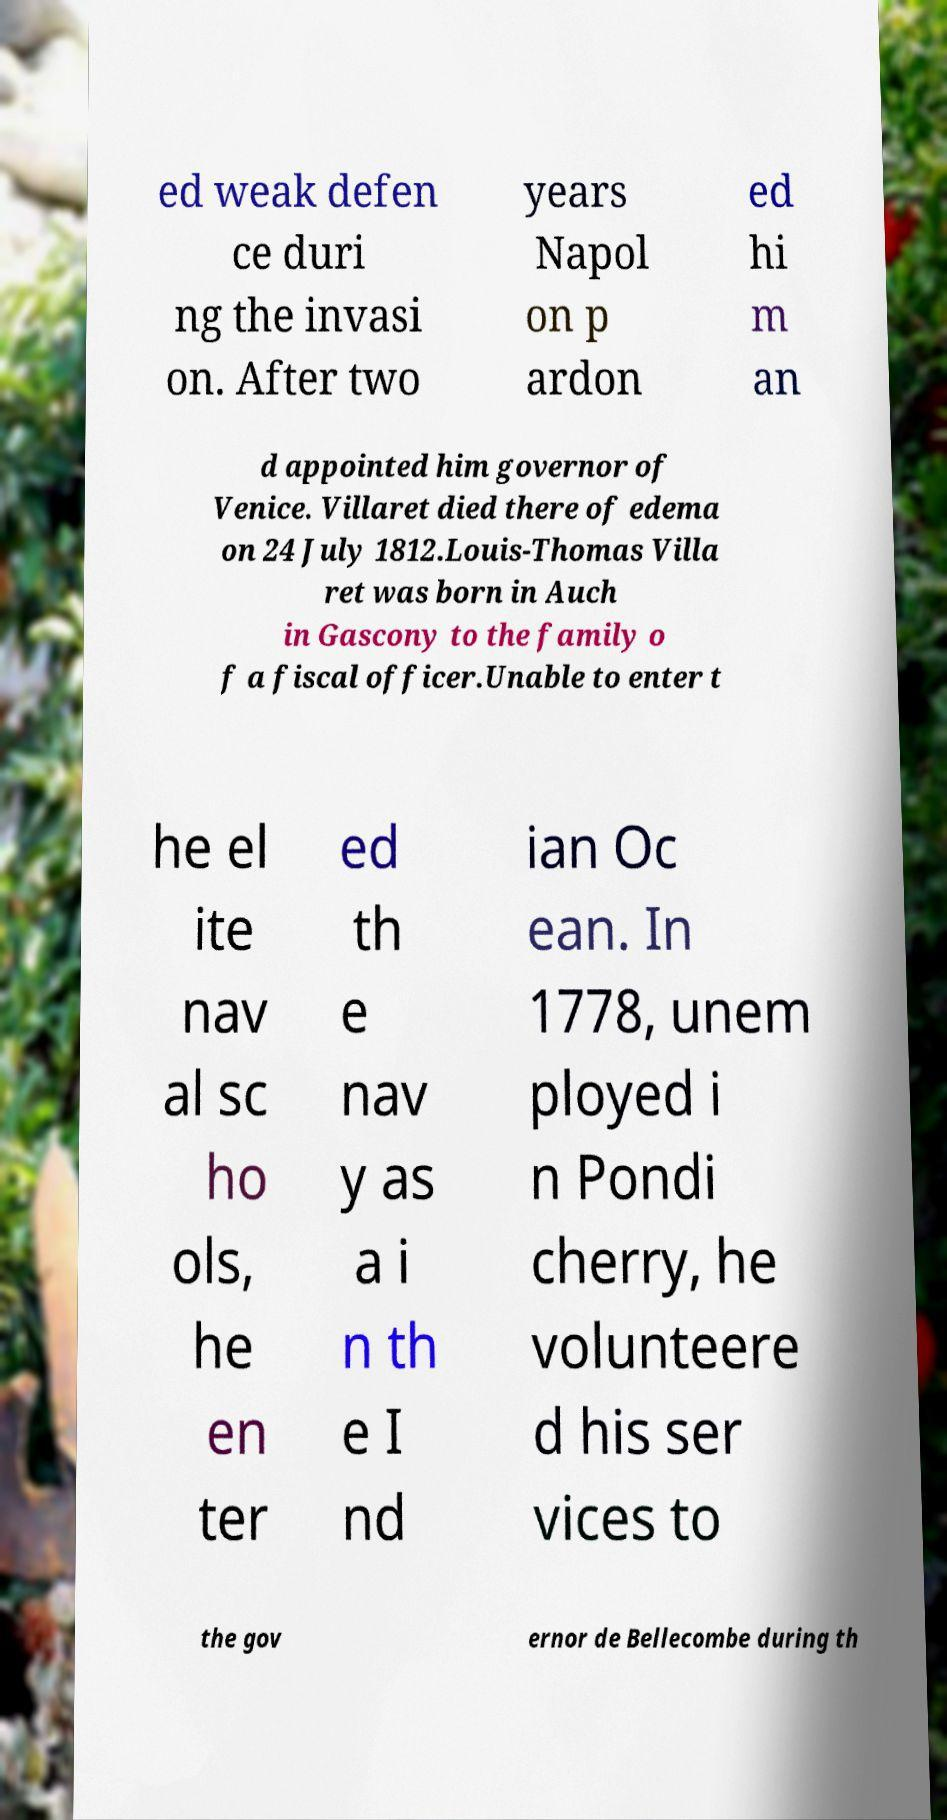Please read and relay the text visible in this image. What does it say? ed weak defen ce duri ng the invasi on. After two years Napol on p ardon ed hi m an d appointed him governor of Venice. Villaret died there of edema on 24 July 1812.Louis-Thomas Villa ret was born in Auch in Gascony to the family o f a fiscal officer.Unable to enter t he el ite nav al sc ho ols, he en ter ed th e nav y as a i n th e I nd ian Oc ean. In 1778, unem ployed i n Pondi cherry, he volunteere d his ser vices to the gov ernor de Bellecombe during th 